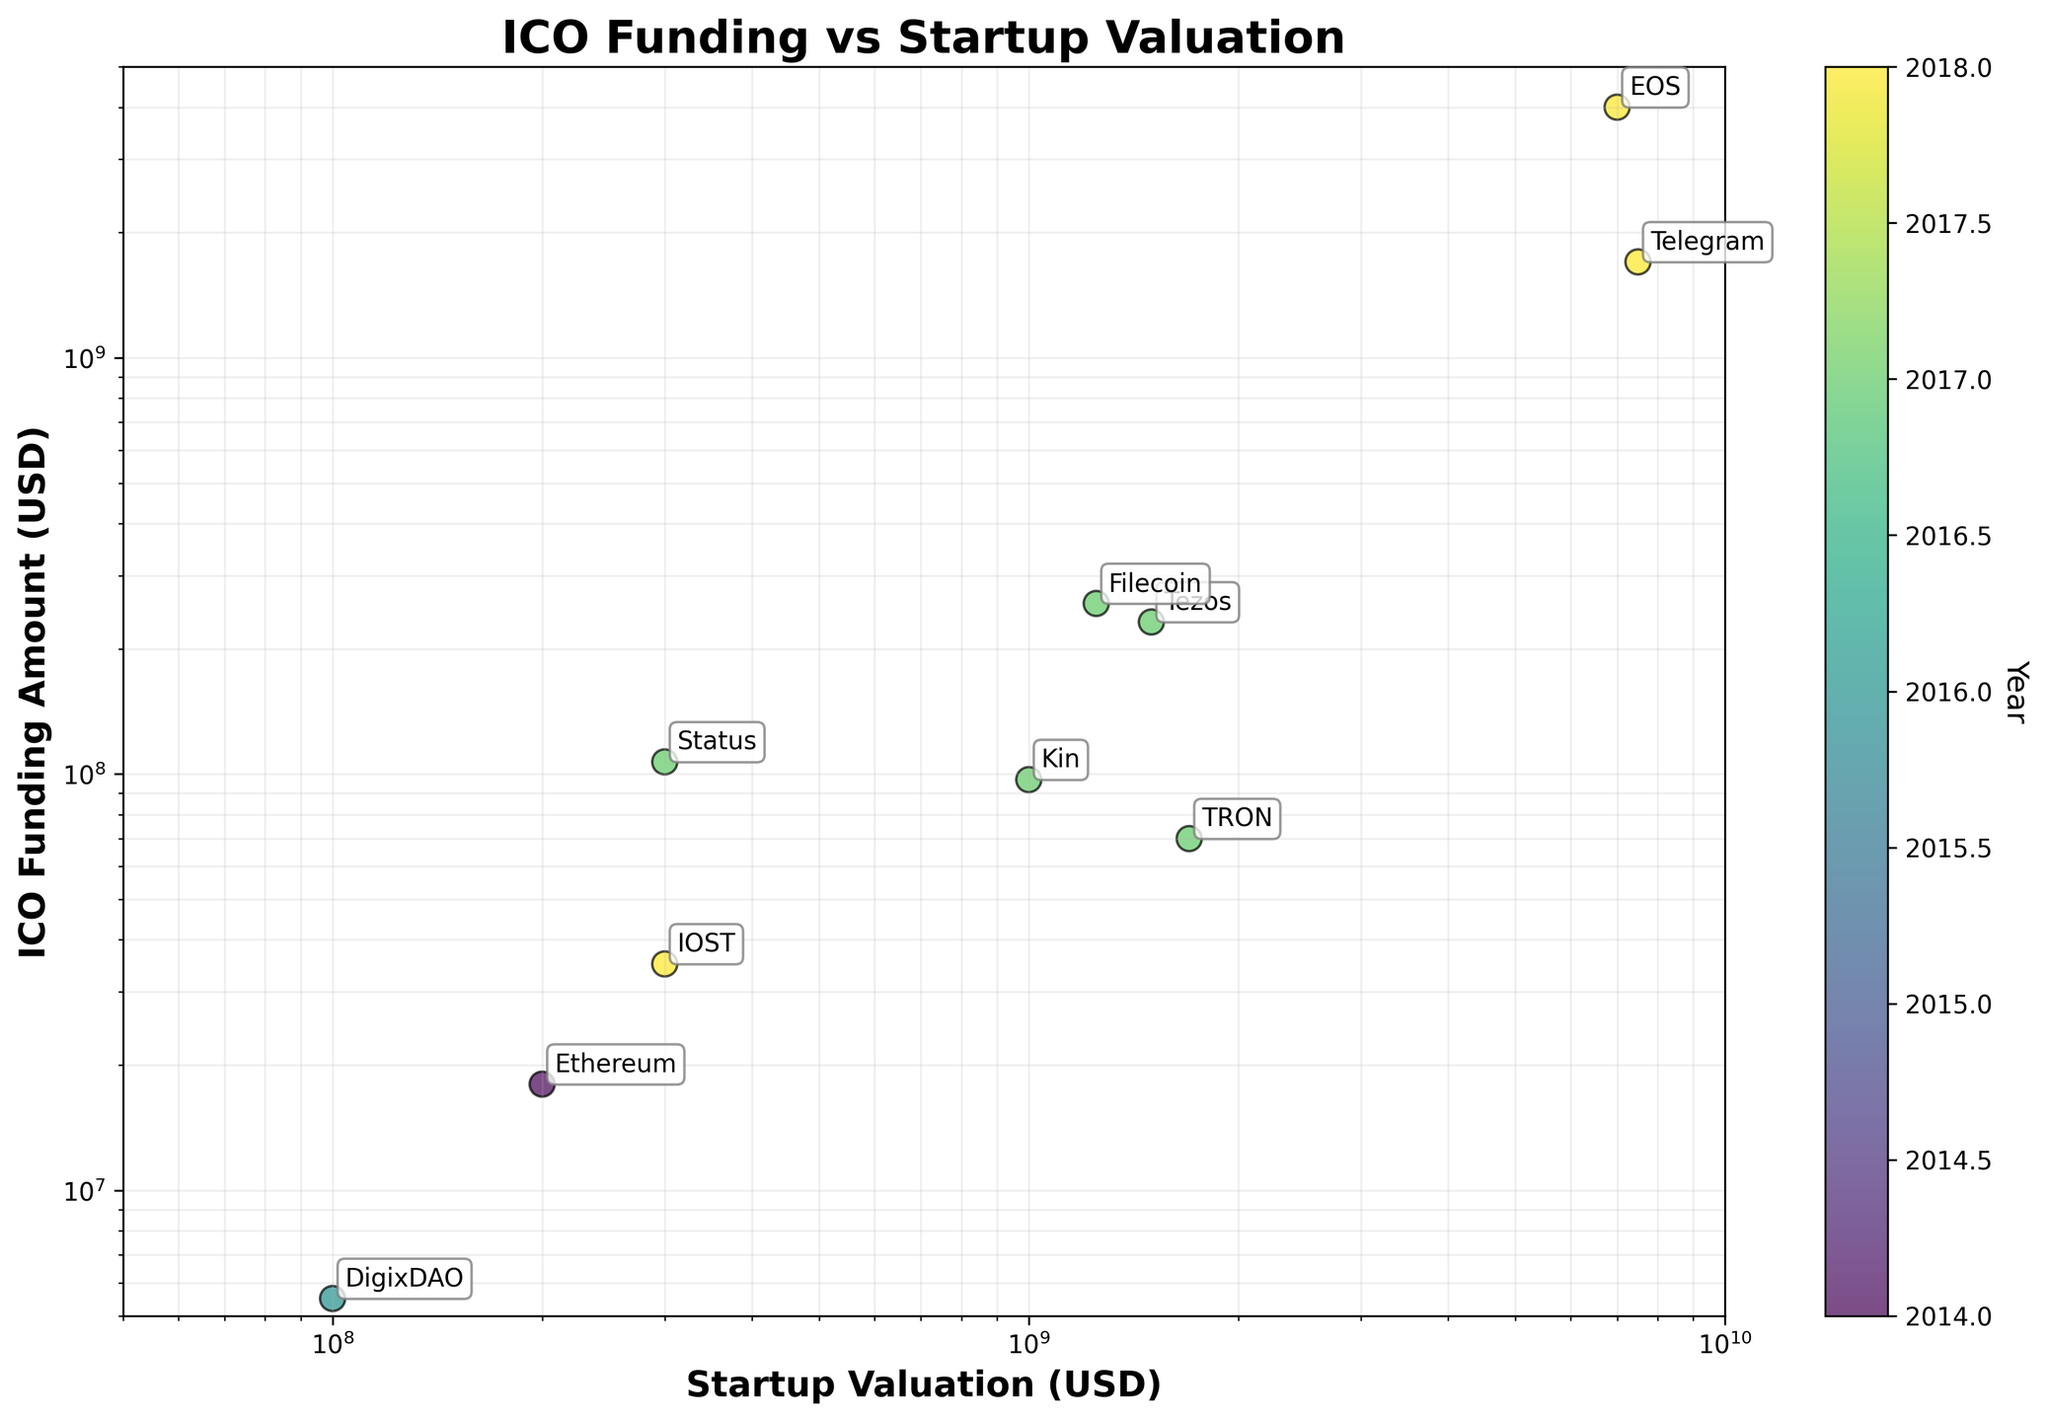What's the title of the plot? The title is found at the top of the plot, and its function is to describe the main topic of the visualized data. The title reads "ICO Funding vs Startup Valuation".
Answer: ICO Funding vs Startup Valuation How many data points are displayed in the plot? Each company's name in the plot represents a data point. By counting these names, we can determine that there are 10 data points in total.
Answer: 10 What is the range of the ICO funding amounts displayed on the plot? The y-axis represents the ICO funding amounts, and by looking at the axis with the log scale, the range spans from approximately just above $5,000,000 to nearly $5,000,000,000.
Answer: Approximately $5 million to $5 billion Which company has the highest startup valuation? By locating the data point farthest to the right on the x-axis (which represents startup valuation), we can see that EOS has the highest startup valuation.
Answer: EOS What are the axes labels for the plot? Axes labels tell us what each axis represents. Here, the x-axis is labeled "Startup Valuation (USD)" and the y-axis is labeled "ICO Funding Amount (USD)".
Answer: Startup Valuation (USD) and ICO Funding Amount (USD) Between which years is the data spread? The color bar represents the year, and the earliest year on the plot is 2014 and the latest is 2018. These years are indicated in the dataset as well.
Answer: 2014 and 2018 Which year has the most number of startups in the plot? The color bar represents different years. By observing the colors of the data points, we notice that the year 2017 has the most startups since it has 6 data points.
Answer: 2017 What is the relationship between ICO funding amount and startup valuation? As we can see from the scatter plot, as the startup valuation increases (x-axis), the ICO funding amount (y-axis) also tends to increase. However, higher valuations show a wider range of ICO funding amounts.
Answer: Positive correlation, but with wider variance at higher valuations Compare the funding amounts of Telegram and Filecoin. Which one received more funding? By identifying the data points for Telegram and Filecoin based on their labels, Telegram's data point is higher on the y-axis compared to Filecoin, indicating it received more funding.
Answer: Telegram Which year did the company with the lowest startup valuation conduct its ICO? The company with the lowest startup valuation is DigixDAO, positioned closest to the left on the x-axis, and it conducted its ICO in 2016.
Answer: 2016 